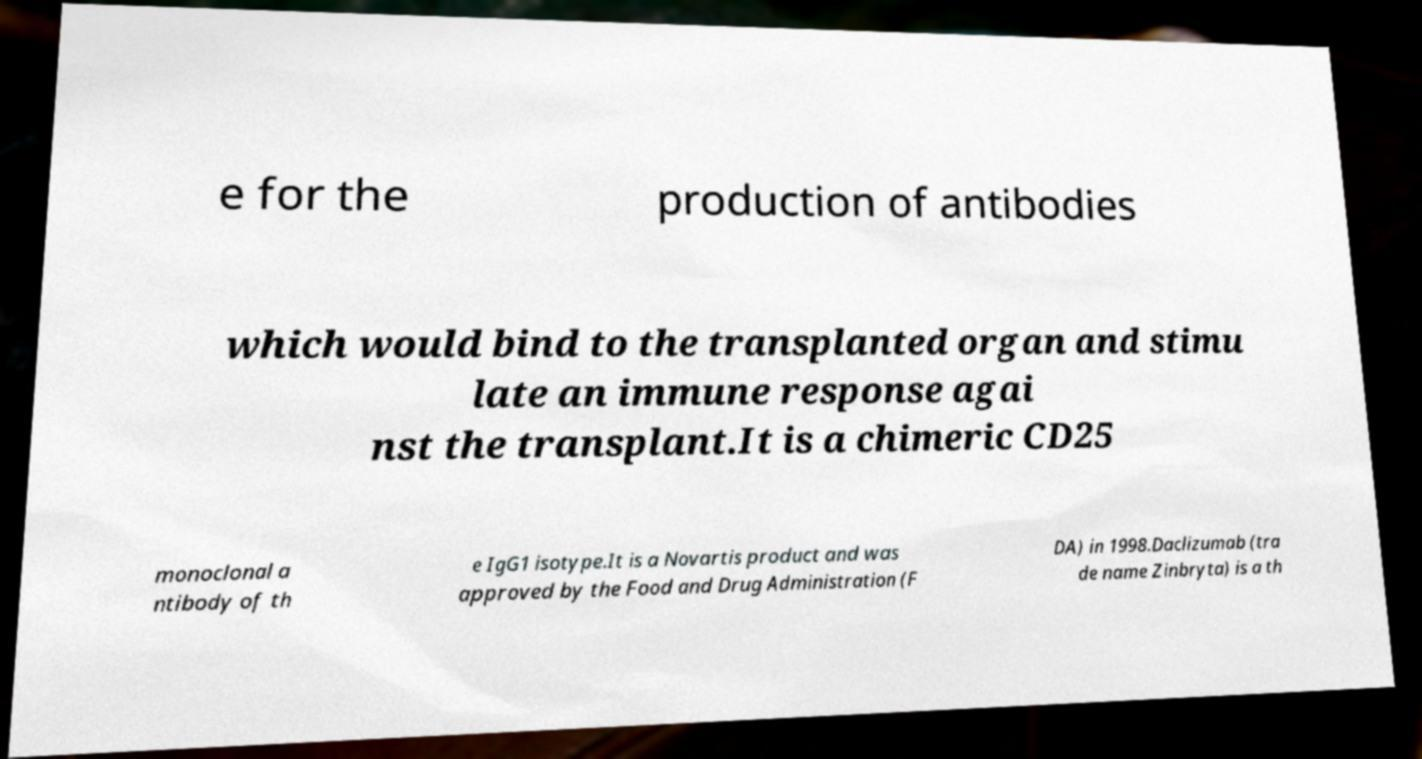For documentation purposes, I need the text within this image transcribed. Could you provide that? e for the production of antibodies which would bind to the transplanted organ and stimu late an immune response agai nst the transplant.It is a chimeric CD25 monoclonal a ntibody of th e IgG1 isotype.It is a Novartis product and was approved by the Food and Drug Administration (F DA) in 1998.Daclizumab (tra de name Zinbryta) is a th 